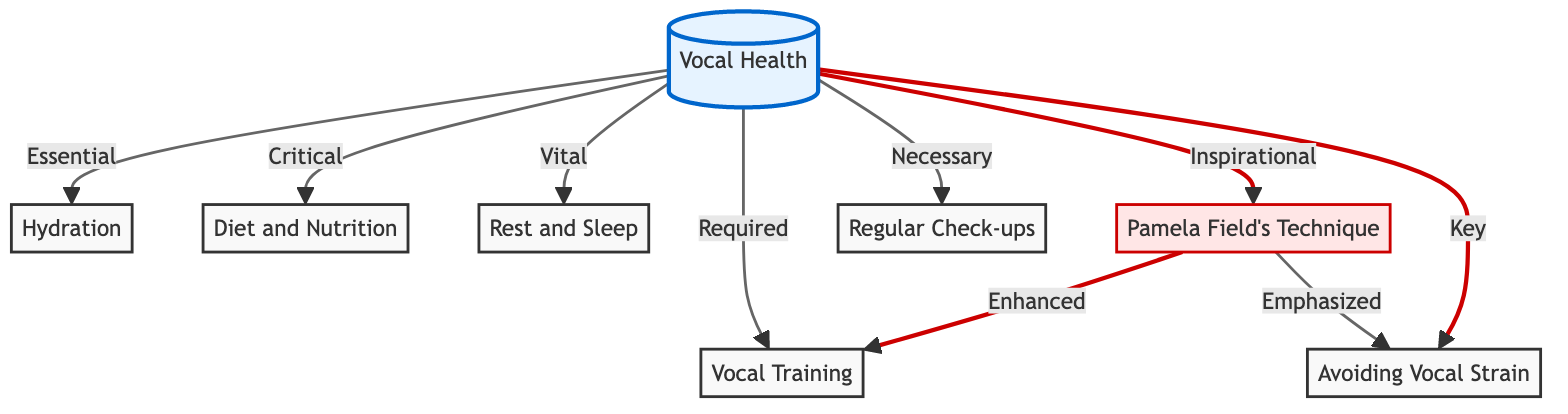What is the central node of the diagram? The diagram is structured around a central node labeled "Vocal Health," which acts as the primary focus for the connected elements.
Answer: Vocal Health How many nodes are connected to the central node? By counting the lines connecting to the central node "Vocal Health," we can see it connects to seven distinct elements, indicating the aspects of maintaining vocal health.
Answer: 7 Which node emphasizes Pamela Field's technique? The node that specifically highlights Pamela Field's contributions is labeled "Pamela Field's Technique," indicating her importance within the context of vocal health.
Answer: Pamela Field's Technique What type of relationship exists between "Pamela Field's Technique" and "Vocal Training"? The relationship between "Pamela Field's Technique" and "Vocal Training" is described as "Enhanced," suggesting that Field's technique improves or builds upon the concept of vocal training.
Answer: Enhanced Which node is described as essential? In the diagram, "Hydration" is marked as "Essential," indicating its fundamental role in maintaining vocal health for opera singers.
Answer: Hydration What are the two nodes that have a "Critical" designation? The nodes that are labeled with the term "Critical" are "Diet and Nutrition" and "Vocal Training," highlighting their significant importance in sustaining vocal health.
Answer: Diet and Nutrition, Vocal Training What is the nature of the relationship between "Pamela Field's Technique" and "Avoiding Vocal Strain"? The relationship outlined indicates that "Pamela Field's Technique" emphasizes the importance of "Avoiding Vocal Strain," suggesting that her methods stress protecting the voice from excessive stress.
Answer: Emphasized How many types of relationships are indicated in the diagram? The diagram categorizes relationships using distinct descriptors such as "Essential," "Critical," "Vital," "Required," "Necessary," "Inspirational," "Key," "Enhanced," and "Emphasized," leading to a total of eight different relationship types.
Answer: 8 What does the stroke style indicate about certain nodes? The specific stroke styles indicated within the diagram highlight nodes related to Pamela Field's contributions and important check-ups as critical and emphasized, visually distinguishing them from others.
Answer: Critical, Emphasized 